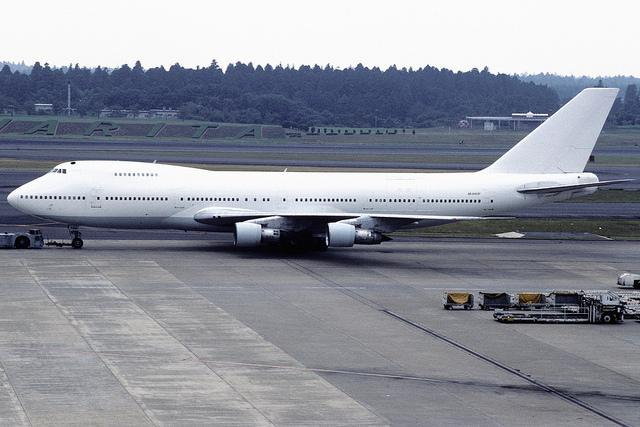Why is there no logo on the plane? private 